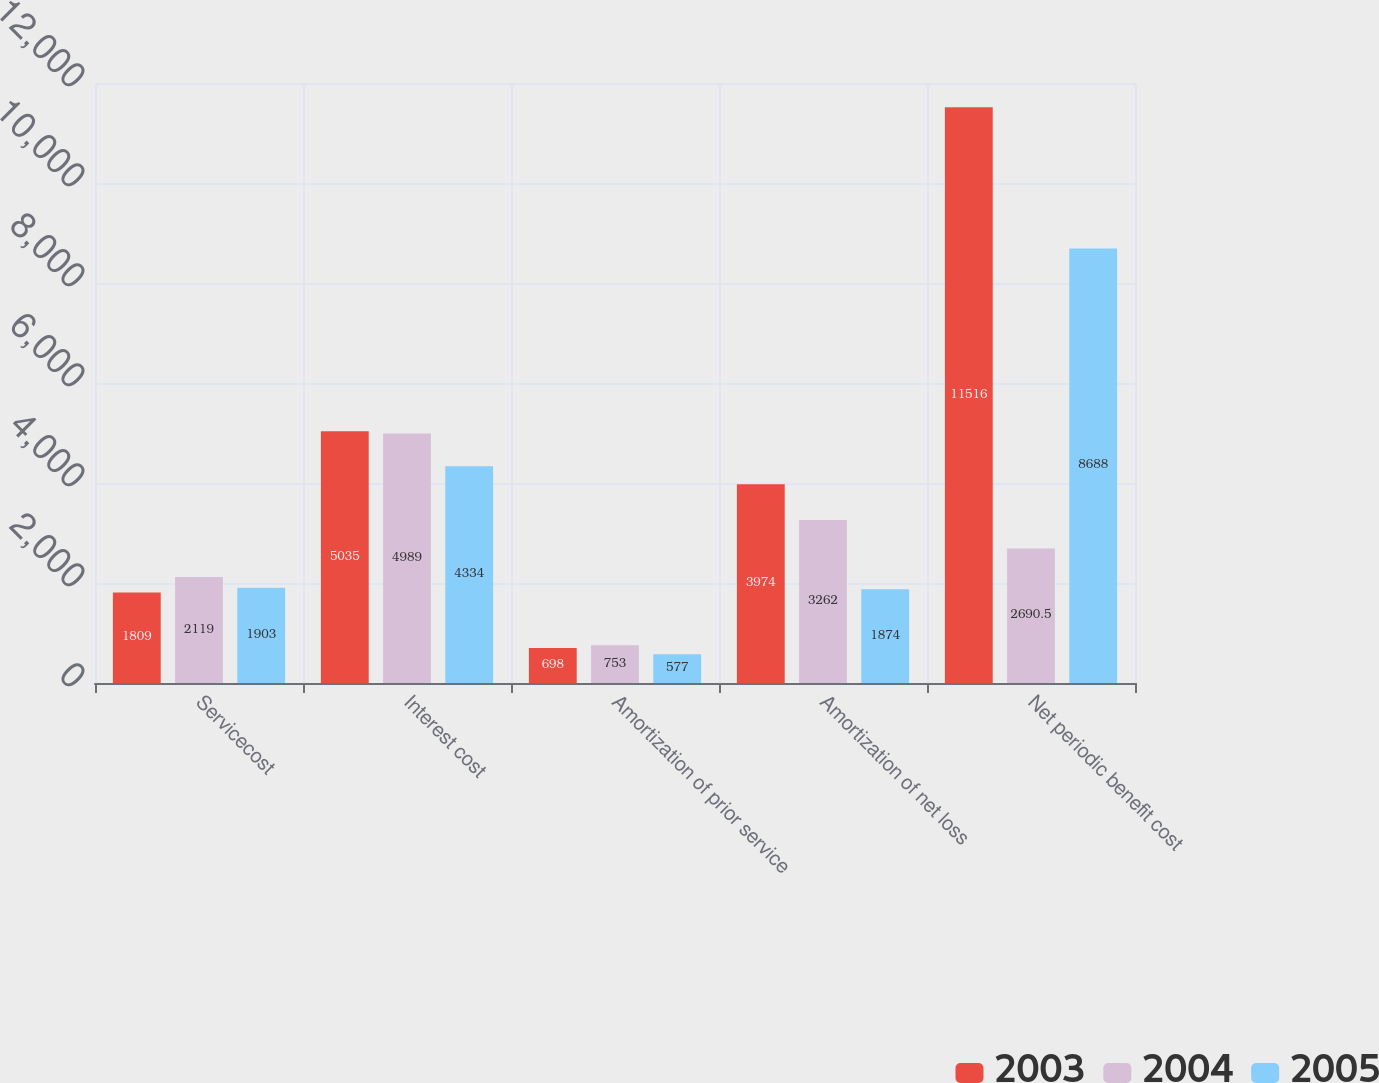<chart> <loc_0><loc_0><loc_500><loc_500><stacked_bar_chart><ecel><fcel>Servicecost<fcel>Interest cost<fcel>Amortization of prior service<fcel>Amortization of net loss<fcel>Net periodic benefit cost<nl><fcel>2003<fcel>1809<fcel>5035<fcel>698<fcel>3974<fcel>11516<nl><fcel>2004<fcel>2119<fcel>4989<fcel>753<fcel>3262<fcel>2690.5<nl><fcel>2005<fcel>1903<fcel>4334<fcel>577<fcel>1874<fcel>8688<nl></chart> 